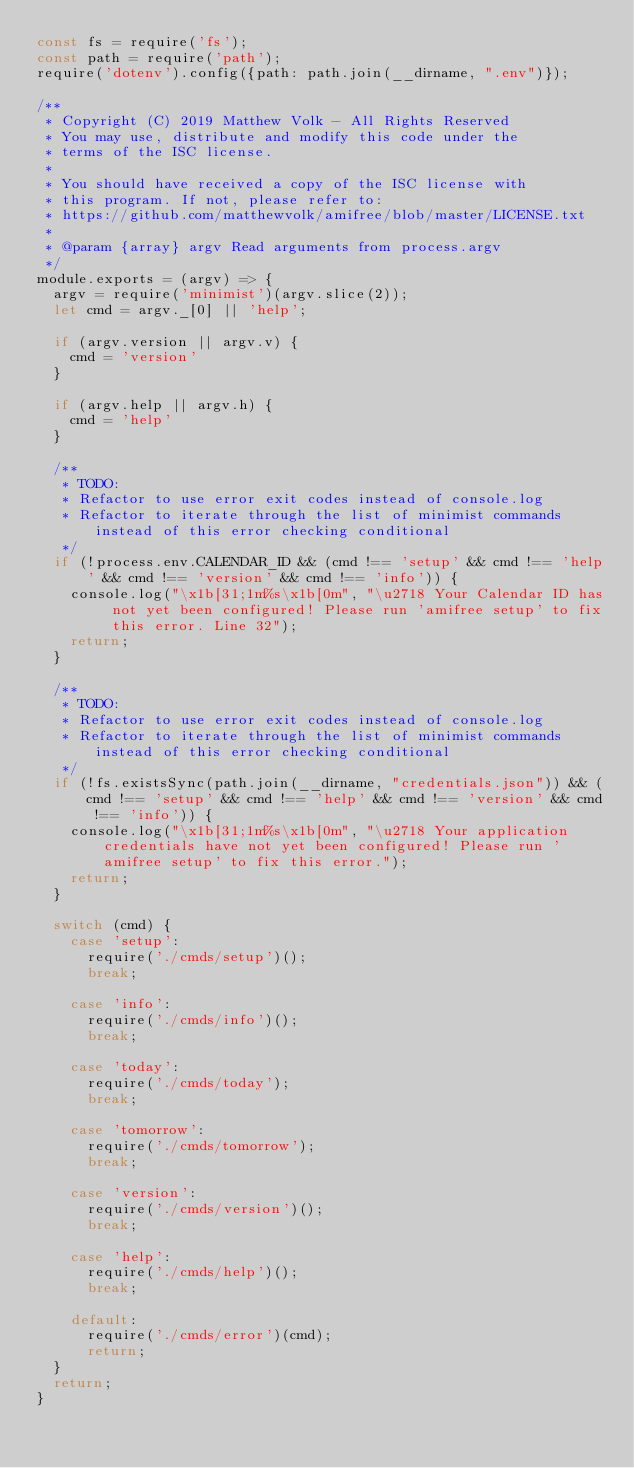Convert code to text. <code><loc_0><loc_0><loc_500><loc_500><_JavaScript_>const fs = require('fs');
const path = require('path');
require('dotenv').config({path: path.join(__dirname, ".env")});

/**
 * Copyright (C) 2019 Matthew Volk - All Rights Reserved
 * You may use, distribute and modify this code under the
 * terms of the ISC license.
 *
 * You should have received a copy of the ISC license with
 * this program. If not, please refer to:  
 * https://github.com/matthewvolk/amifree/blob/master/LICENSE.txt
 *
 * @param {array} argv Read arguments from process.argv
 */
module.exports = (argv) => {
  argv = require('minimist')(argv.slice(2));
  let cmd = argv._[0] || 'help';

  if (argv.version || argv.v) {
    cmd = 'version'
  }

  if (argv.help || argv.h) {
    cmd = 'help'
  }

  /**
   * TODO: 
   * Refactor to use error exit codes instead of console.log
   * Refactor to iterate through the list of minimist commands instead of this error checking conditional
   */
  if (!process.env.CALENDAR_ID && (cmd !== 'setup' && cmd !== 'help' && cmd !== 'version' && cmd !== 'info')) {
    console.log("\x1b[31;1m%s\x1b[0m", "\u2718 Your Calendar ID has not yet been configured! Please run 'amifree setup' to fix this error. Line 32");
    return;
  }
  
  /**
   * TODO:
   * Refactor to use error exit codes instead of console.log
   * Refactor to iterate through the list of minimist commands instead of this error checking conditional
   */
  if (!fs.existsSync(path.join(__dirname, "credentials.json")) && (cmd !== 'setup' && cmd !== 'help' && cmd !== 'version' && cmd !== 'info')) {
    console.log("\x1b[31;1m%s\x1b[0m", "\u2718 Your application credentials have not yet been configured! Please run 'amifree setup' to fix this error.");
    return;
  }

  switch (cmd) {
    case 'setup':
      require('./cmds/setup')();
      break;

    case 'info':
      require('./cmds/info')();
      break;

    case 'today':
      require('./cmds/today');
      break;

    case 'tomorrow':
      require('./cmds/tomorrow');
      break;

    case 'version':
      require('./cmds/version')();
      break;

    case 'help':
      require('./cmds/help')();
      break;

    default:
      require('./cmds/error')(cmd);
      return;
  }
  return;
}
</code> 